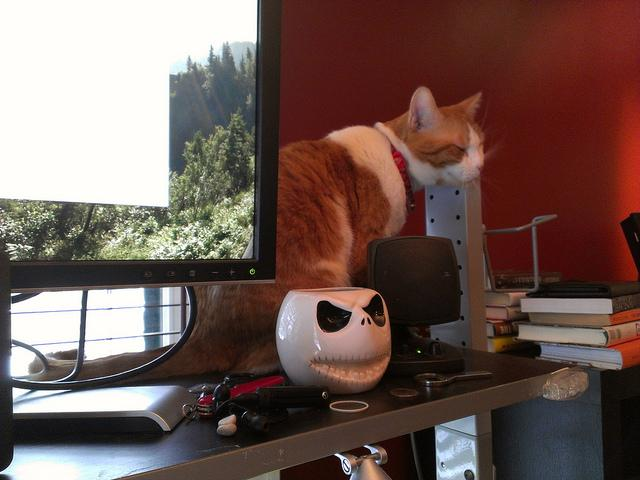What word is appropriate to describe the animal near the books? cat 